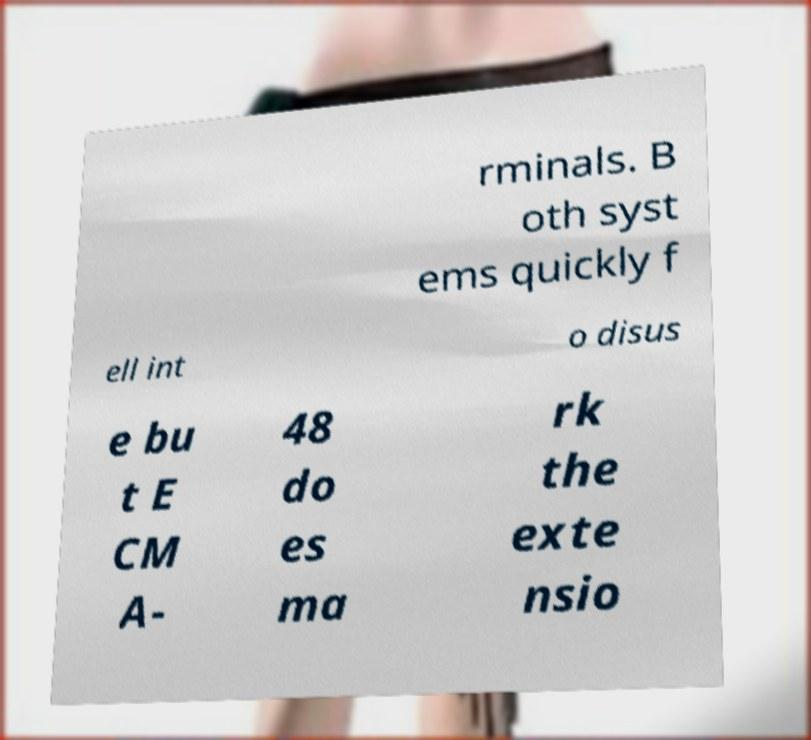Please read and relay the text visible in this image. What does it say? rminals. B oth syst ems quickly f ell int o disus e bu t E CM A- 48 do es ma rk the exte nsio 